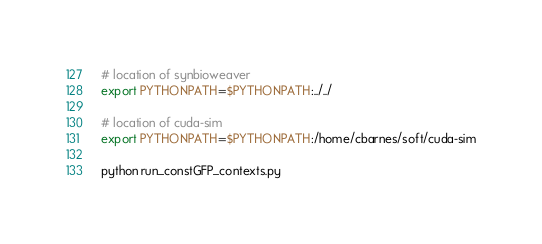<code> <loc_0><loc_0><loc_500><loc_500><_Bash_># location of synbioweaver
export PYTHONPATH=$PYTHONPATH:../../

# location of cuda-sim
export PYTHONPATH=$PYTHONPATH:/home/cbarnes/soft/cuda-sim

python run_constGFP_contexts.py 
</code> 